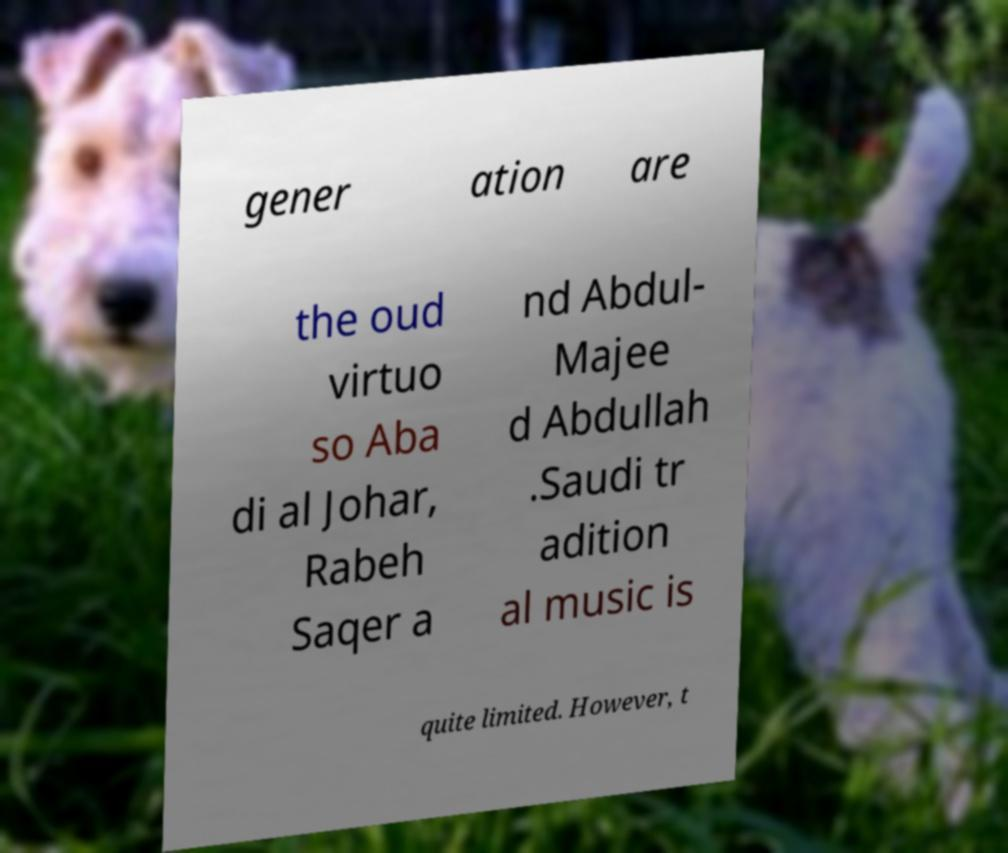There's text embedded in this image that I need extracted. Can you transcribe it verbatim? gener ation are the oud virtuo so Aba di al Johar, Rabeh Saqer a nd Abdul- Majee d Abdullah .Saudi tr adition al music is quite limited. However, t 